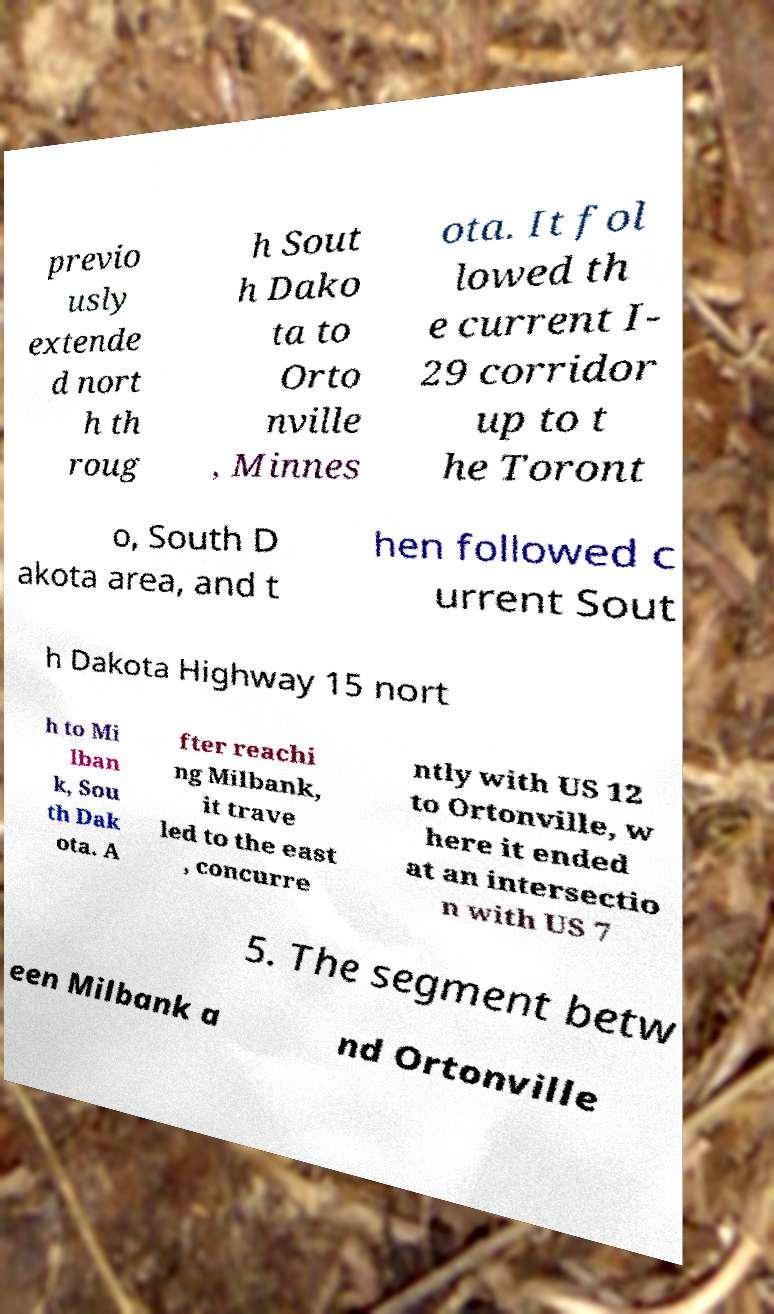There's text embedded in this image that I need extracted. Can you transcribe it verbatim? previo usly extende d nort h th roug h Sout h Dako ta to Orto nville , Minnes ota. It fol lowed th e current I- 29 corridor up to t he Toront o, South D akota area, and t hen followed c urrent Sout h Dakota Highway 15 nort h to Mi lban k, Sou th Dak ota. A fter reachi ng Milbank, it trave led to the east , concurre ntly with US 12 to Ortonville, w here it ended at an intersectio n with US 7 5. The segment betw een Milbank a nd Ortonville 